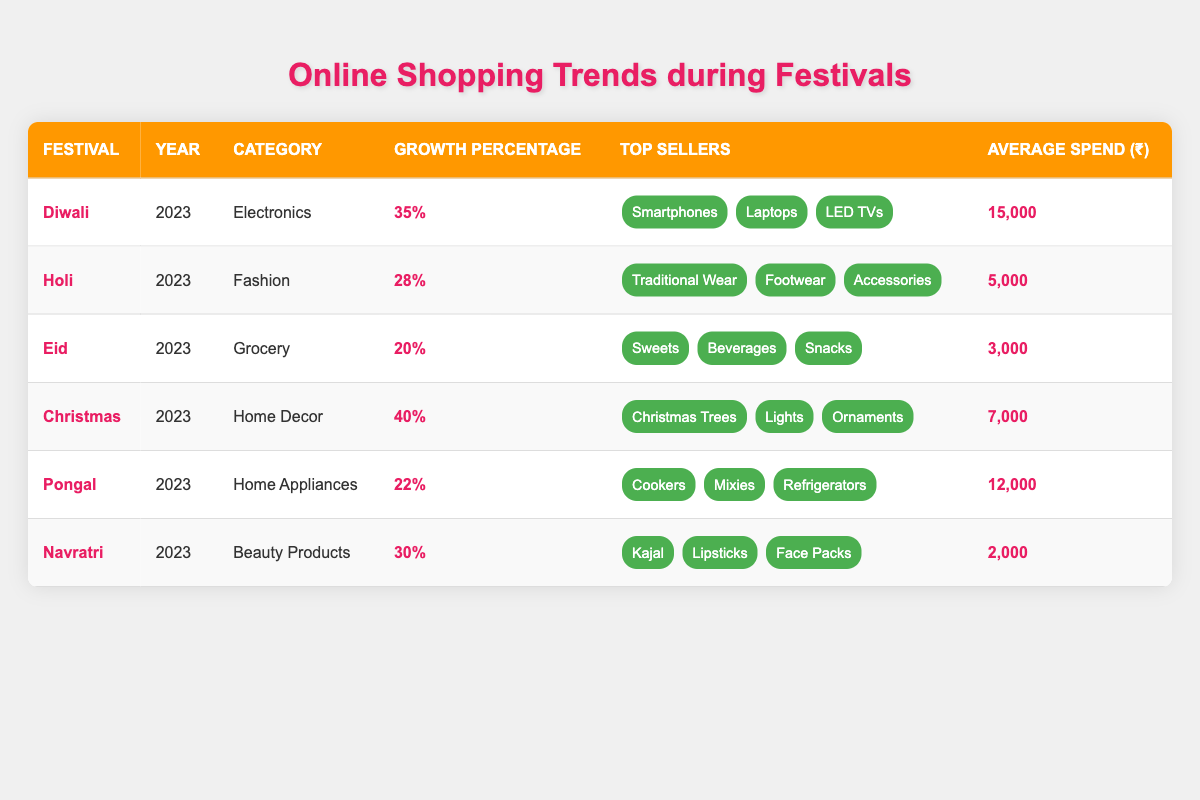What is the top-selling category during Diwali in 2023? The table lists "Electronics" as the category under "Diwali" for the year 2023.
Answer: Electronics Which festival showed the highest growth percentage in 2023? By scanning the growth percentages, "Christmas" has the highest at 40%.
Answer: 40% What is the average spend on beauty products during Navratri in 2023? The table indicates the average spend for beauty products during Navratri as ₹2,000.
Answer: ₹2,000 How much more is spent on average during Diwali compared to Eid? Diwali's average spend is ₹15,000 and Eid's is ₹3,000. The difference is ₹15,000 - ₹3,000 = ₹12,000.
Answer: ₹12,000 Is the growth percentage for Holi higher than that of Pongal? Holi's growth percentage is 28%, while Pongal's is 22%. Since 28% > 22%, the statement is true.
Answer: Yes What is the total average spend across all festivals listed in the table? Adding all average spends: ₹15,000 + ₹5,000 + ₹3,000 + ₹7,000 + ₹12,000 + ₹2,000 = ₹44,000. With 6 festivals, the average is ₹44,000 / 6 = ₹7,333.33.
Answer: ₹7,333.33 How many different categories of products are listed across the festivals? The categories are Electronics, Fashion, Grocery, Home Decor, Home Appliances, and Beauty Products, totaling 6 different categories.
Answer: 6 Is there any festival where the average spend is below ₹5,000? The table shows Eid (₹3,000) and Navratri (₹2,000) both below ₹5,000. Therefore, the answer is true.
Answer: Yes What percentage increase does the average spend during Christmas have compared to Holi? Christmas spend is ₹7,000, Holi is ₹5,000. The increase is ₹7,000 - ₹5,000 = ₹2,000. The percentage increase is (₹2,000 / ₹5,000) * 100 = 40%.
Answer: 40% Which festival saw a higher average spend, Pongal or Christmas? Comparing average spends: Pongal at ₹12,000 and Christmas at ₹7,000, so Pongal has a higher average spend.
Answer: Pongal 